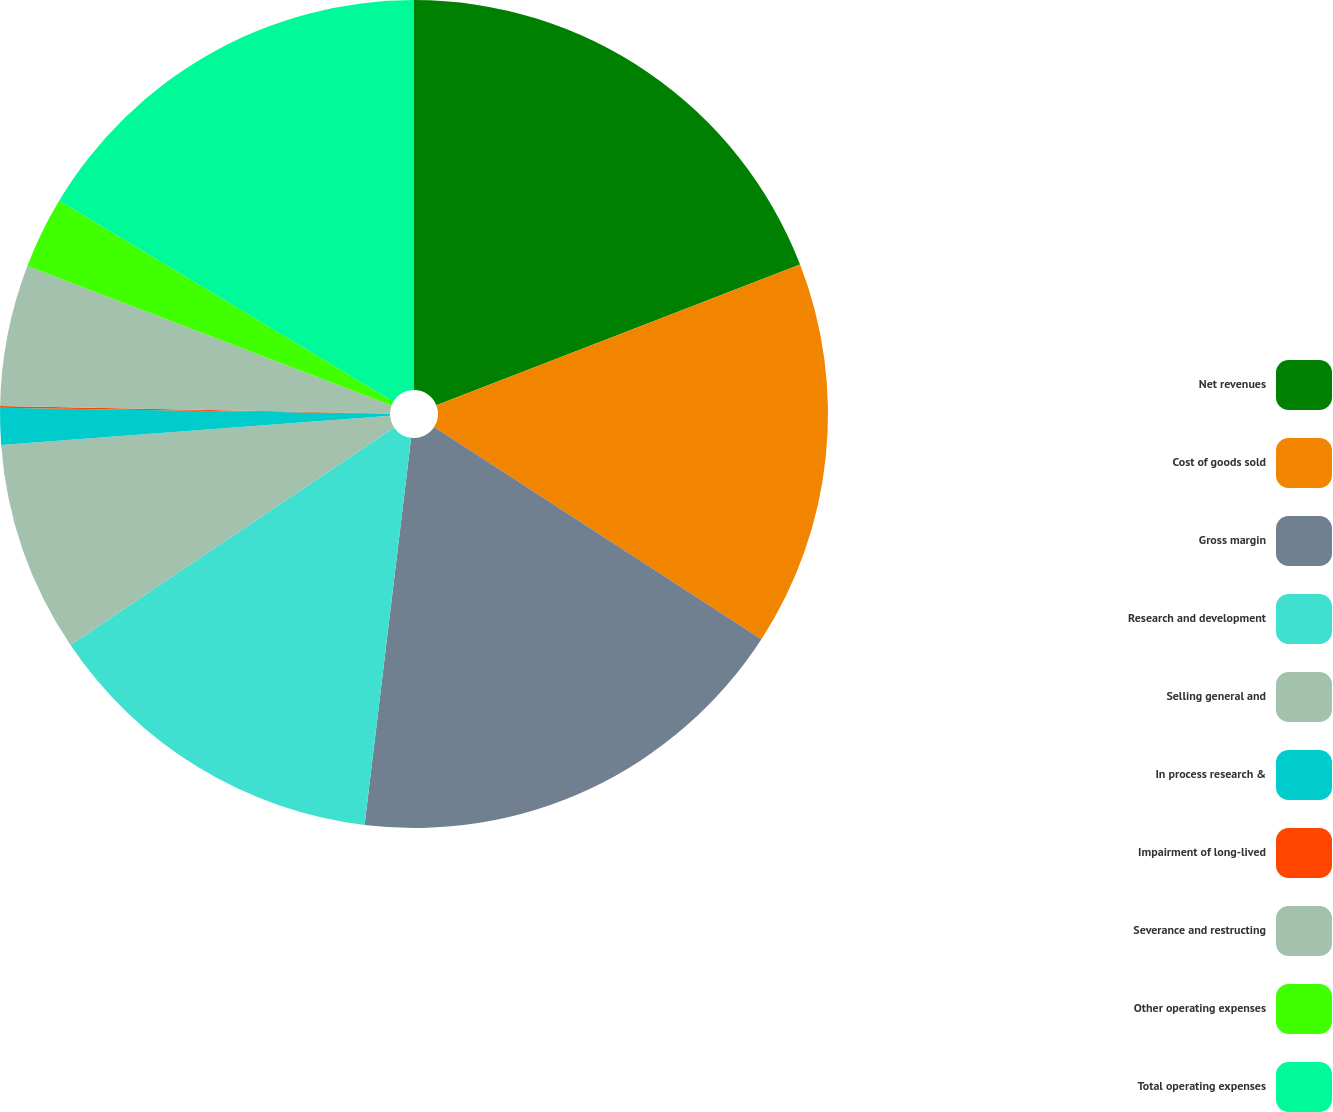<chart> <loc_0><loc_0><loc_500><loc_500><pie_chart><fcel>Net revenues<fcel>Cost of goods sold<fcel>Gross margin<fcel>Research and development<fcel>Selling general and<fcel>In process research &<fcel>Impairment of long-lived<fcel>Severance and restructing<fcel>Other operating expenses<fcel>Total operating expenses<nl><fcel>19.12%<fcel>15.03%<fcel>17.75%<fcel>13.67%<fcel>8.23%<fcel>1.43%<fcel>0.07%<fcel>5.51%<fcel>2.79%<fcel>16.39%<nl></chart> 